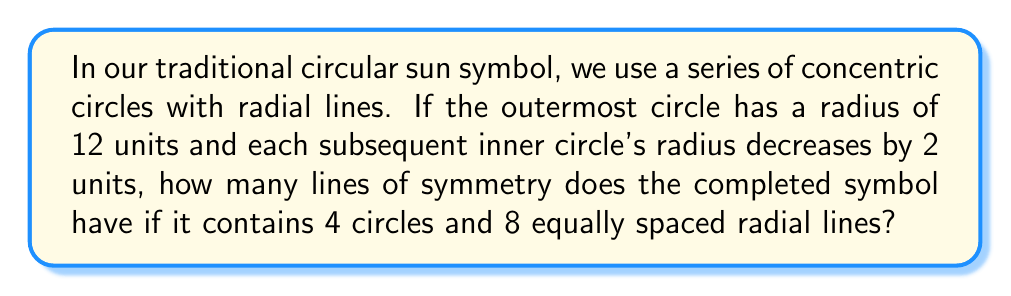Provide a solution to this math problem. Let's approach this step-by-step:

1) First, we need to understand what contributes to the symmetry of this symbol:
   a) The concentric circles
   b) The equally spaced radial lines

2) For circular shapes, lines of symmetry pass through the center. The number of lines of symmetry is determined by the number of equally spaced divisions around the circle.

3) In this case, we have 8 equally spaced radial lines. This means the symbol can be divided into 8 equal parts.

4) Each of these 8 divisions creates a line of symmetry. The lines of symmetry will pass through:
   a) Each radial line
   b) The midpoint between each pair of adjacent radial lines

5) Therefore, the total number of lines of symmetry is:
   $$8 \text{ (through radial lines)} + 8 \text{ (between radial lines)} = 16$$

6) It's worth noting that the number of concentric circles doesn't affect the number of lines of symmetry in this case, as long as they're perfectly circular and share the same center.

[asy]
size(200);
for(int i=0; i<4; ++i) {
  draw(circle((0,0), 12-2*i), black);
}
for(int j=0; j<8; ++j) {
  draw((0,0)--(12*dir(j*45)), black);
}
[/asy]

This diagram illustrates the symbol described, showing the 4 concentric circles and 8 radial lines.
Answer: 16 lines of symmetry 